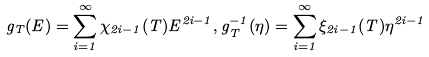<formula> <loc_0><loc_0><loc_500><loc_500>g _ { T } ( E ) = \sum _ { i = 1 } ^ { \infty } \chi _ { 2 i - 1 } ( T ) E ^ { 2 i - 1 } , g _ { T } ^ { - 1 } ( \eta ) = \sum _ { i = 1 } ^ { \infty } \xi _ { 2 i - 1 } ( T ) \eta ^ { 2 i - 1 }</formula> 